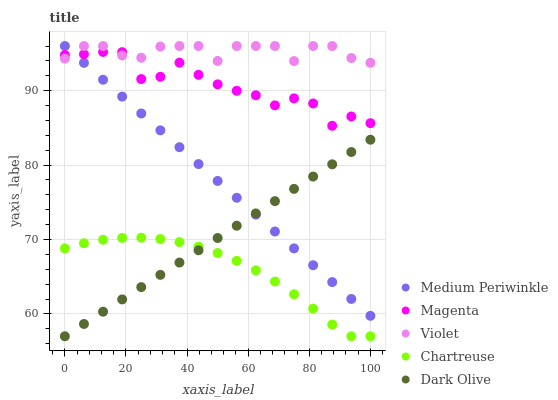Does Chartreuse have the minimum area under the curve?
Answer yes or no. Yes. Does Violet have the maximum area under the curve?
Answer yes or no. Yes. Does Dark Olive have the minimum area under the curve?
Answer yes or no. No. Does Dark Olive have the maximum area under the curve?
Answer yes or no. No. Is Medium Periwinkle the smoothest?
Answer yes or no. Yes. Is Magenta the roughest?
Answer yes or no. Yes. Is Dark Olive the smoothest?
Answer yes or no. No. Is Dark Olive the roughest?
Answer yes or no. No. Does Dark Olive have the lowest value?
Answer yes or no. Yes. Does Medium Periwinkle have the lowest value?
Answer yes or no. No. Does Violet have the highest value?
Answer yes or no. Yes. Does Dark Olive have the highest value?
Answer yes or no. No. Is Chartreuse less than Magenta?
Answer yes or no. Yes. Is Magenta greater than Dark Olive?
Answer yes or no. Yes. Does Medium Periwinkle intersect Dark Olive?
Answer yes or no. Yes. Is Medium Periwinkle less than Dark Olive?
Answer yes or no. No. Is Medium Periwinkle greater than Dark Olive?
Answer yes or no. No. Does Chartreuse intersect Magenta?
Answer yes or no. No. 